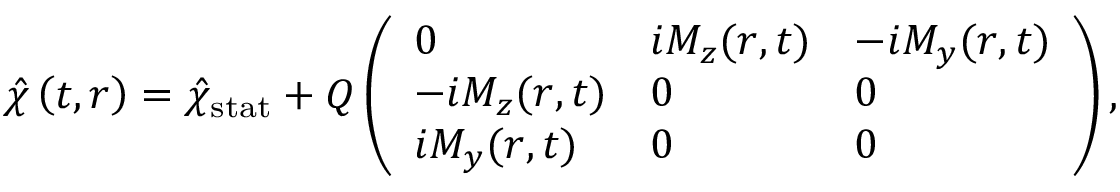Convert formula to latex. <formula><loc_0><loc_0><loc_500><loc_500>\hat { \chi } \left ( t , r \right ) = { \hat { \chi } } _ { s t a t } + Q \left ( \begin{array} { l l l } { 0 } & { i M _ { z } ( { r } , t ) } & { - i M _ { y } ( { r } , t ) } \\ { - i M _ { z } ( { r } , t ) } & { 0 } & { 0 } \\ { i M _ { y } ( { r } , t ) } & { 0 } & { 0 } \end{array} \right ) ,</formula> 